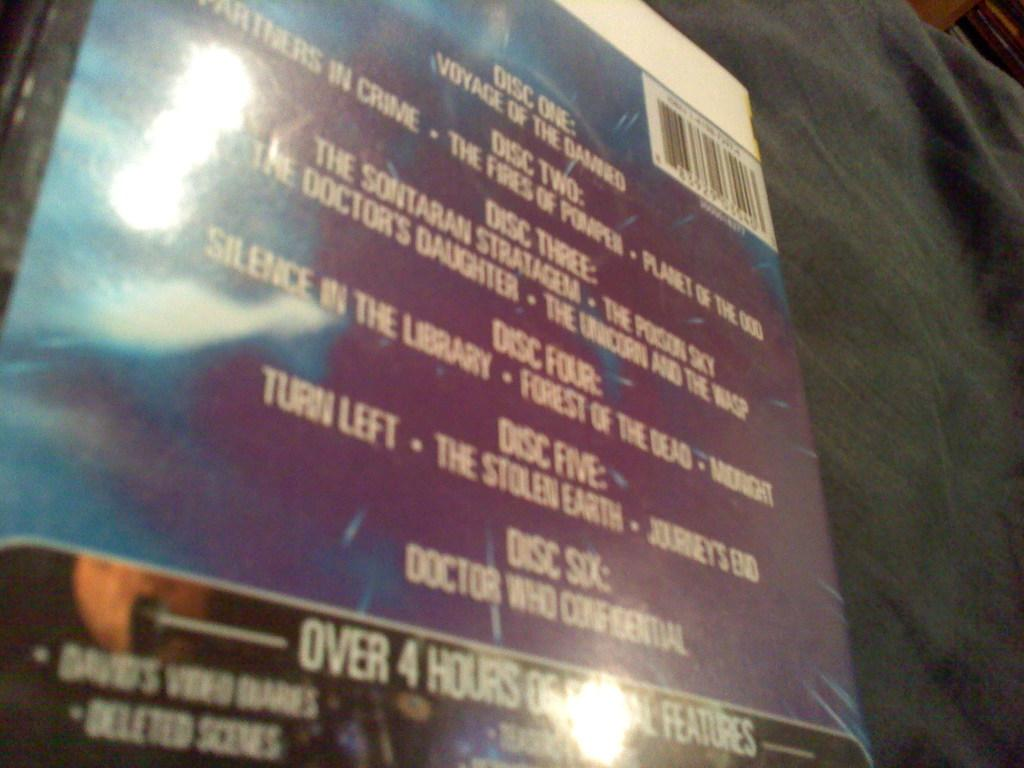<image>
Share a concise interpretation of the image provided. The back of a CD box displays the contents on each of the six discs. 